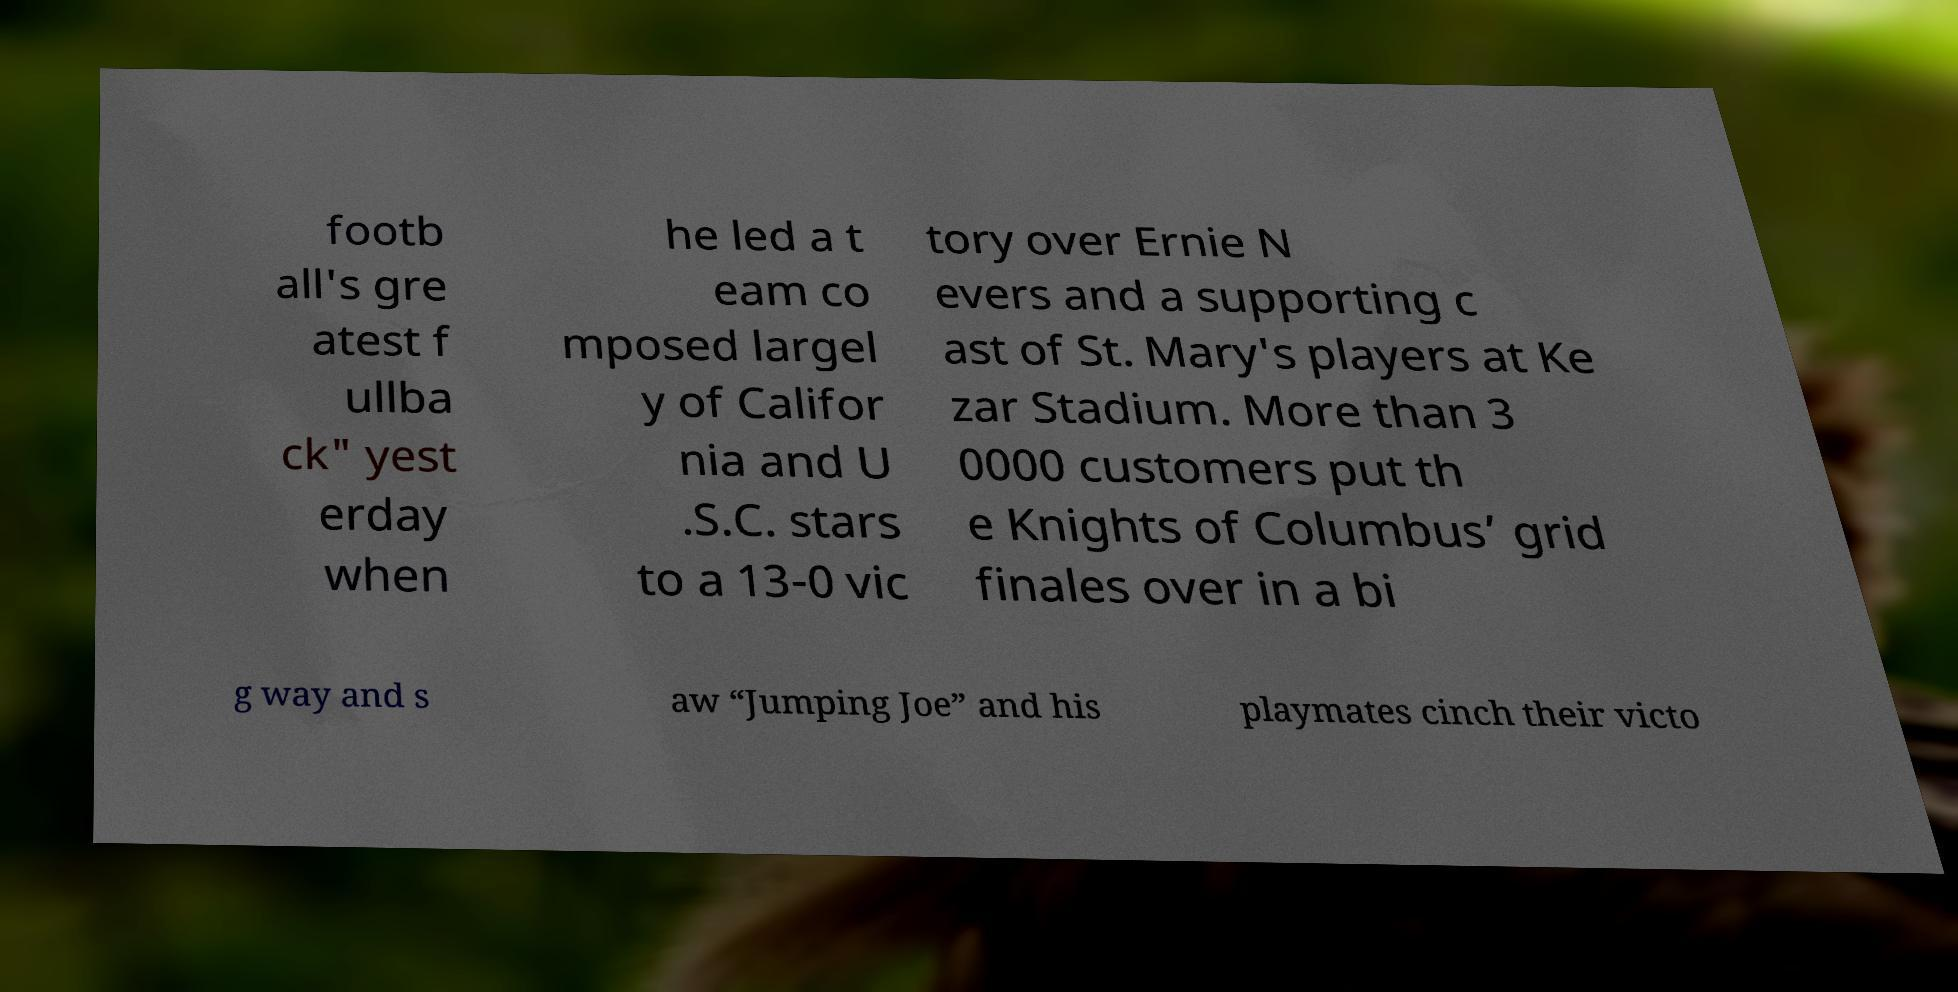Please identify and transcribe the text found in this image. footb all's gre atest f ullba ck" yest erday when he led a t eam co mposed largel y of Califor nia and U .S.C. stars to a 13-0 vic tory over Ernie N evers and a supporting c ast of St. Mary's players at Ke zar Stadium. More than 3 0000 customers put th e Knights of Columbus’ grid finales over in a bi g way and s aw “Jumping Joe” and his playmates cinch their victo 